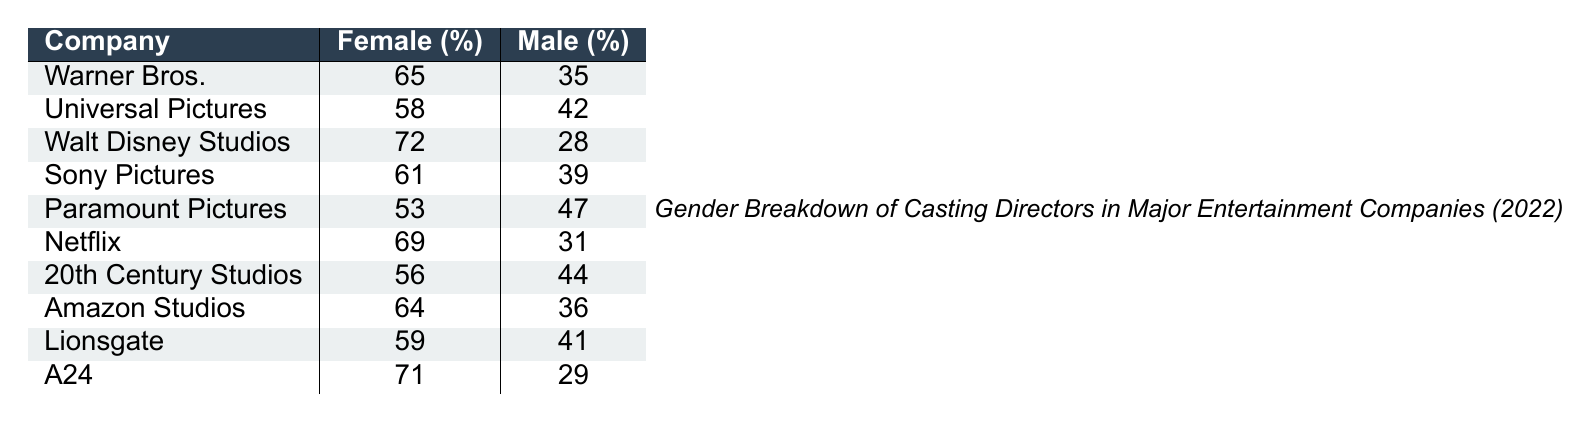What is the percentage of female casting directors at Walt Disney Studios? The table shows that Walt Disney Studios has 72 female casting directors out of a total of 100 casting directors. Therefore, the percentage of female casting directors is 72%.
Answer: 72% Which company has the highest percentage of male casting directors? By comparing the male percentages in the table, Paramount Pictures has the highest at 47%.
Answer: 47% What is the total number of casting directors for Netflix and Amazon Studios combined? The total for Netflix is 100 (69 female + 31 male) and for Amazon Studios is also 100 (64 female + 36 male). Therefore, combined they have 200 casting directors.
Answer: 200 Is the percentage of female casting directors greater at Warner Bros. or Sony Pictures? Warner Bros. has 65% female casting directors, while Sony Pictures has 61%. Therefore, the percentage is greater at Warner Bros.
Answer: Warner Bros What is the average percentage of female casting directors across all companies listed? To find the average, add all percentages of female casting directors (65 + 58 + 72 + 61 + 53 + 69 + 56 + 64 + 59 + 71 =  635) and divide by 10 (the total number of companies). This results in an average of 63.5%.
Answer: 63.5% How many companies have a male casting director percentage over 40%? By reviewing the table values, Universal Pictures (42), Paramount Pictures (47), 20th Century Studios (44), and Lionsgate (41) all have male casting director percentages over 40%, totaling four companies.
Answer: 4 Which company has the lowest percentage of female casting directors? Upon inspecting the table, Paramount Pictures has the lowest percentage at 53%.
Answer: 53% Is there a gender breakdown trend showing a correlation between the percentage of female and male casting directors across these companies? Analyzing the data shows that as the percentage of female casting directors increases, the percentage of male casting directors decreases across the companies, indicating an inverse relationship.
Answer: Yes, inverse relationship What is the difference in percentage of female casting directors between A24 and Warner Bros.? A24 has 71% female casting directors and Warner Bros. has 65%. The difference is 71 - 65 = 6%.
Answer: 6% How many companies have more female casting directors than male casting directors? All companies listed have more female casting directors than male casting directors, totaling 10.
Answer: 10 